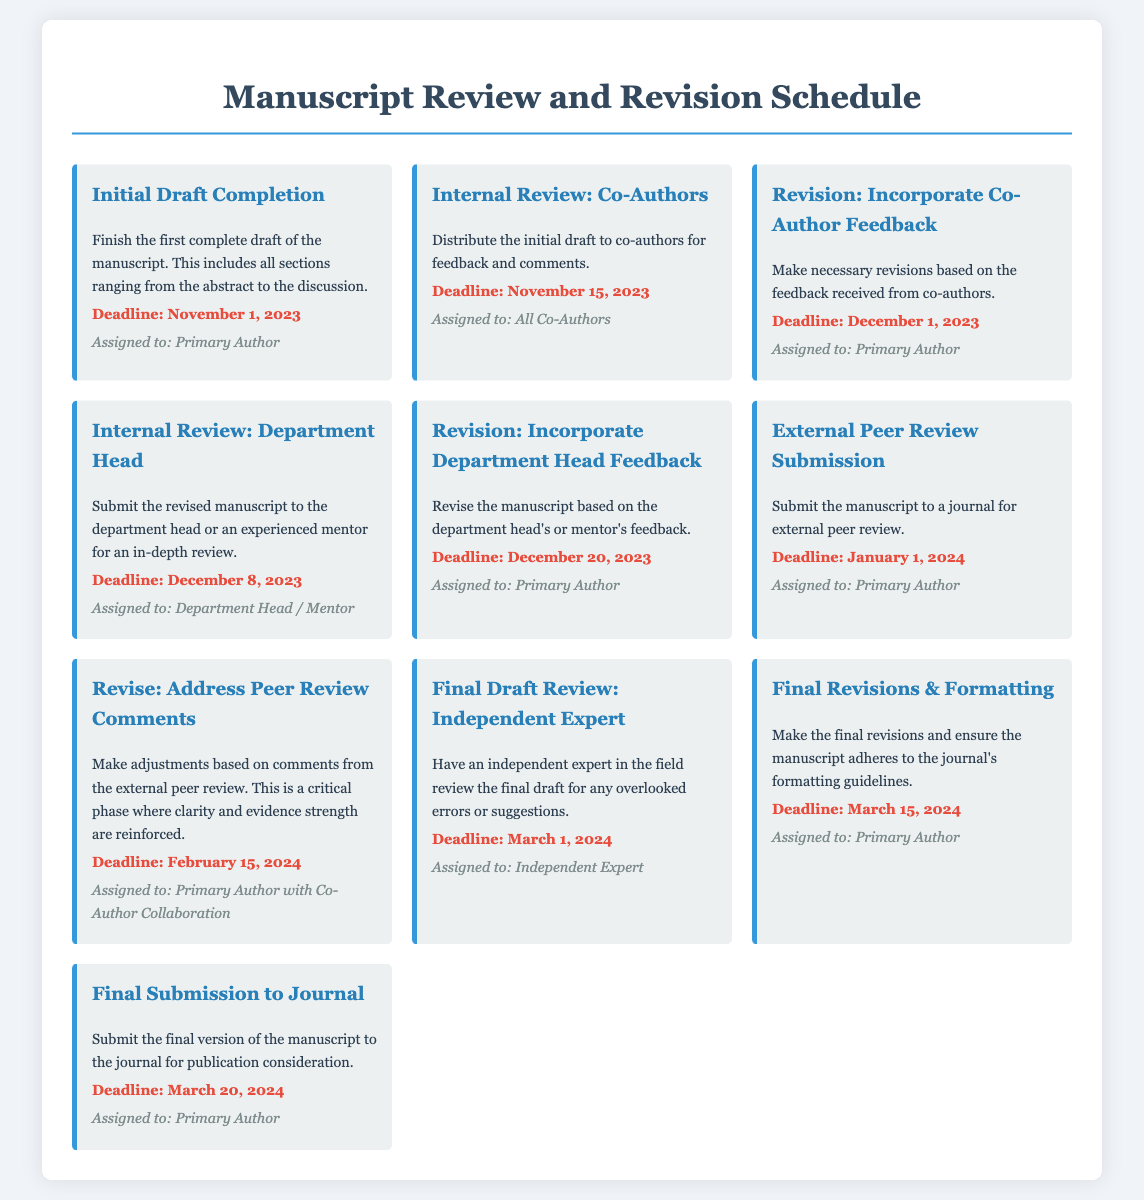What is the deadline for the Initial Draft Completion? The deadline for the Initial Draft Completion is specified in the document.
Answer: November 1, 2023 Who is assigned to the Internal Review: Co-Authors? The assigned person for the Internal Review: Co-Authors is mentioned in the document.
Answer: All Co-Authors What is the date for the External Peer Review Submission? The date for the External Peer Review Submission can be found in the calendar section of the document.
Answer: January 1, 2024 How many revisions are scheduled before the Final Submission? The document lists the number of revisions scheduled before the Final Submission.
Answer: Four What task is due on March 15, 2024? The task due on this date can be identified from the milestone section of the document.
Answer: Final Revisions & Formatting What is the deadline for addressing peer review comments? The deadline for addressing peer review comments is clearly stated in the timeline.
Answer: February 15, 2024 Which milestone is assigned to the Independent Expert? The document specifies which milestone is assigned to the Independent Expert.
Answer: Final Draft Review: Independent Expert What is the last task before the Final Submission to the Journal? The document outlines the last task that must be completed before the final submission.
Answer: Final Revisions & Formatting 